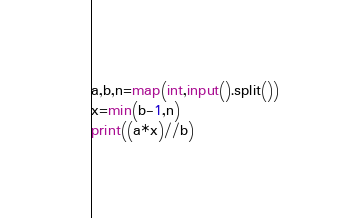Convert code to text. <code><loc_0><loc_0><loc_500><loc_500><_Python_>a,b,n=map(int,input().split())
x=min(b-1,n)
print((a*x)//b)</code> 